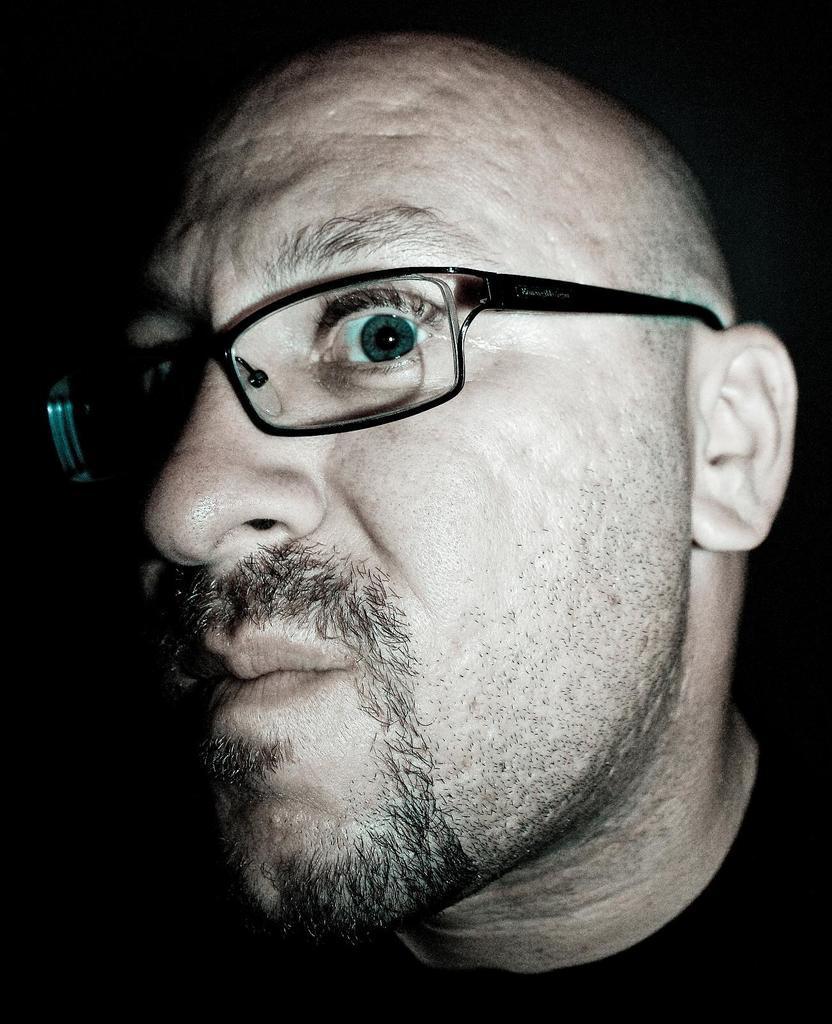Can you describe this image briefly? In this image there is a face of the man wearing a spects. 